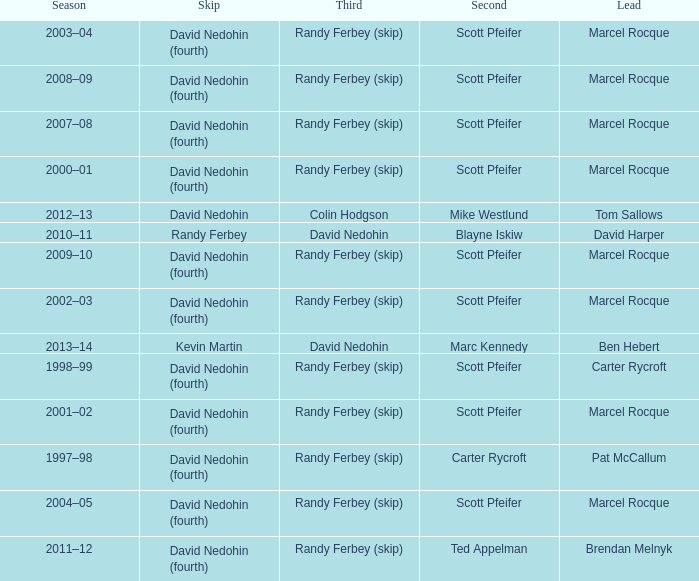Which Second has a Third of david nedohin, and a Lead of ben hebert? Marc Kennedy. 